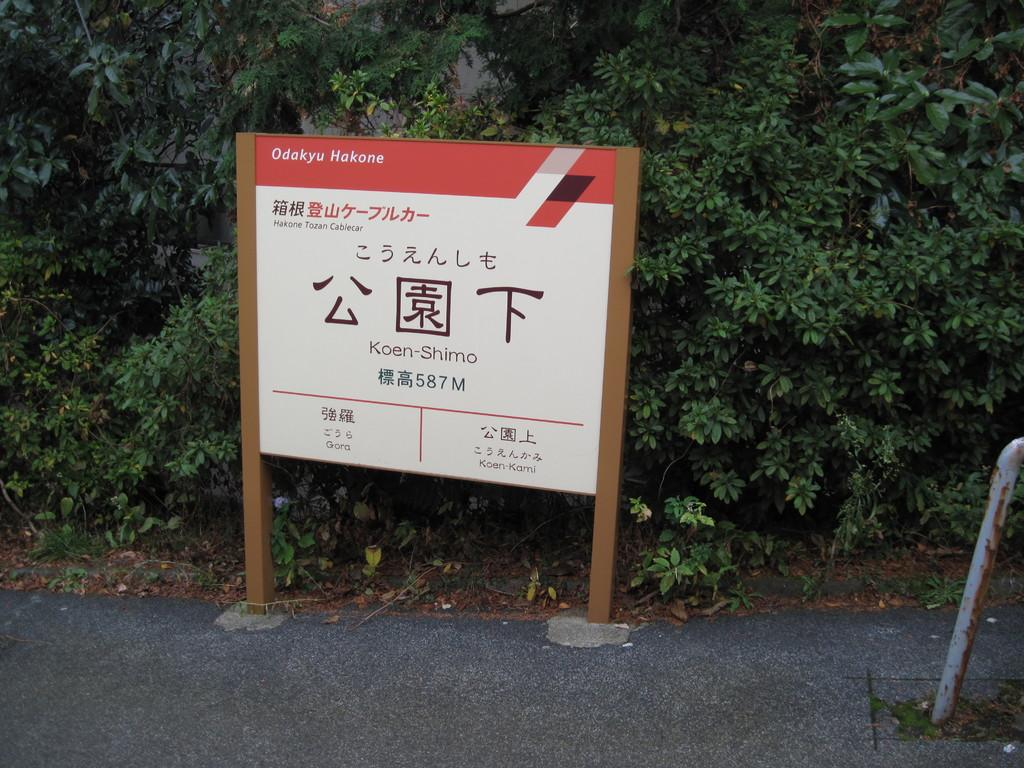What is the main subject of the image? The main subject of the image is a part of the road. What else can be seen in the image besides the road? There is a board with information in the image. What type of vegetation is visible behind the board? There are plants visible behind the board in the image. How many seeds can be seen on the board in the image? There are no seeds present on the board in the image. Is there a beggar visible in the image? There is no beggar visible in the image. 